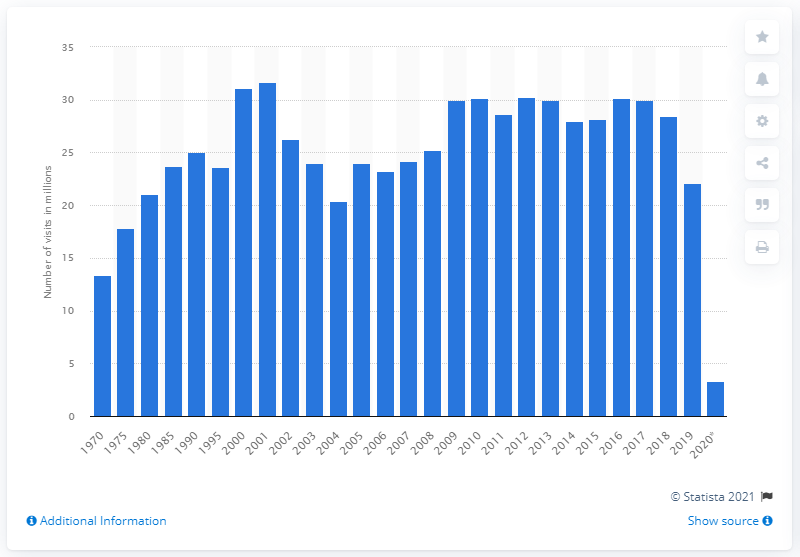Identify some key points in this picture. In 2019, Smithsonian museums and institutions reported a total of 22.1 visits. The Smithsonian museums and institutions recorded 3,300,000 visits in 2020. 